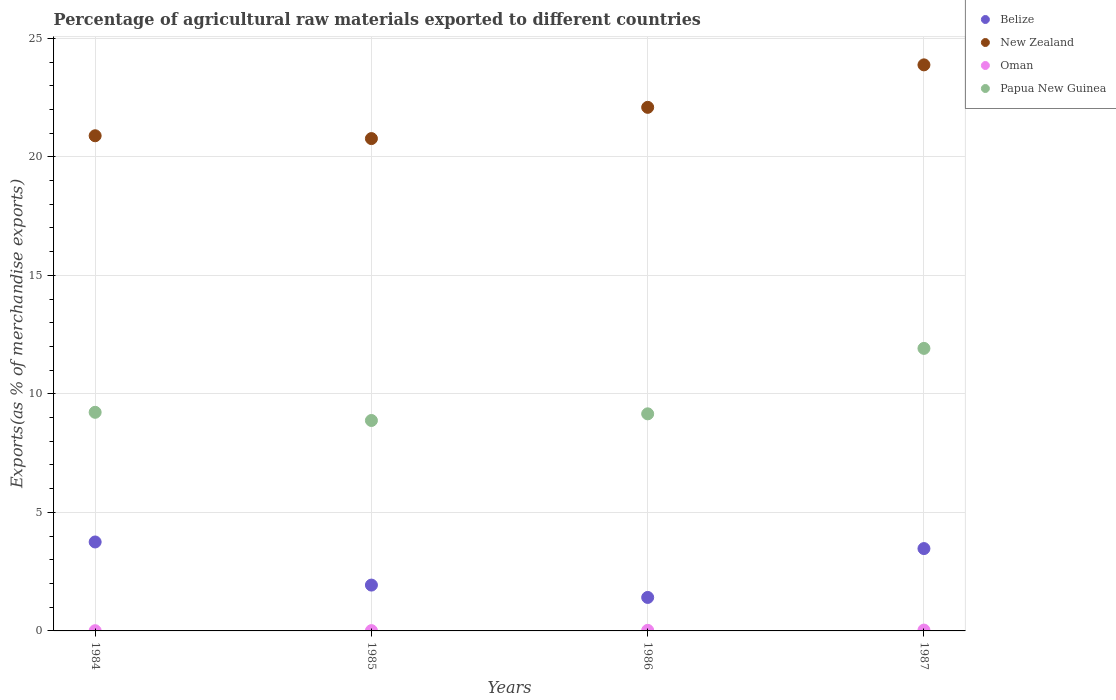What is the percentage of exports to different countries in Belize in 1986?
Give a very brief answer. 1.41. Across all years, what is the maximum percentage of exports to different countries in Belize?
Provide a short and direct response. 3.75. Across all years, what is the minimum percentage of exports to different countries in Oman?
Provide a succinct answer. 0.01. In which year was the percentage of exports to different countries in Belize maximum?
Ensure brevity in your answer.  1984. In which year was the percentage of exports to different countries in Oman minimum?
Give a very brief answer. 1984. What is the total percentage of exports to different countries in Papua New Guinea in the graph?
Keep it short and to the point. 39.18. What is the difference between the percentage of exports to different countries in Papua New Guinea in 1984 and that in 1987?
Provide a short and direct response. -2.7. What is the difference between the percentage of exports to different countries in Belize in 1984 and the percentage of exports to different countries in New Zealand in 1986?
Your answer should be very brief. -18.34. What is the average percentage of exports to different countries in Belize per year?
Provide a succinct answer. 2.64. In the year 1984, what is the difference between the percentage of exports to different countries in Papua New Guinea and percentage of exports to different countries in Belize?
Give a very brief answer. 5.47. In how many years, is the percentage of exports to different countries in Belize greater than 10 %?
Ensure brevity in your answer.  0. What is the ratio of the percentage of exports to different countries in Oman in 1985 to that in 1987?
Keep it short and to the point. 0.35. Is the difference between the percentage of exports to different countries in Papua New Guinea in 1986 and 1987 greater than the difference between the percentage of exports to different countries in Belize in 1986 and 1987?
Keep it short and to the point. No. What is the difference between the highest and the second highest percentage of exports to different countries in Papua New Guinea?
Your answer should be compact. 2.7. What is the difference between the highest and the lowest percentage of exports to different countries in New Zealand?
Make the answer very short. 3.11. Is the sum of the percentage of exports to different countries in Papua New Guinea in 1985 and 1987 greater than the maximum percentage of exports to different countries in New Zealand across all years?
Your answer should be compact. No. Is the percentage of exports to different countries in Belize strictly greater than the percentage of exports to different countries in New Zealand over the years?
Offer a very short reply. No. Is the percentage of exports to different countries in Belize strictly less than the percentage of exports to different countries in Papua New Guinea over the years?
Provide a succinct answer. Yes. How many dotlines are there?
Keep it short and to the point. 4. Does the graph contain any zero values?
Your answer should be compact. No. How are the legend labels stacked?
Your answer should be compact. Vertical. What is the title of the graph?
Provide a short and direct response. Percentage of agricultural raw materials exported to different countries. What is the label or title of the X-axis?
Provide a short and direct response. Years. What is the label or title of the Y-axis?
Ensure brevity in your answer.  Exports(as % of merchandise exports). What is the Exports(as % of merchandise exports) in Belize in 1984?
Your answer should be very brief. 3.75. What is the Exports(as % of merchandise exports) in New Zealand in 1984?
Ensure brevity in your answer.  20.89. What is the Exports(as % of merchandise exports) of Oman in 1984?
Your answer should be very brief. 0.01. What is the Exports(as % of merchandise exports) in Papua New Guinea in 1984?
Give a very brief answer. 9.22. What is the Exports(as % of merchandise exports) in Belize in 1985?
Keep it short and to the point. 1.93. What is the Exports(as % of merchandise exports) of New Zealand in 1985?
Your response must be concise. 20.77. What is the Exports(as % of merchandise exports) in Oman in 1985?
Your response must be concise. 0.01. What is the Exports(as % of merchandise exports) of Papua New Guinea in 1985?
Keep it short and to the point. 8.88. What is the Exports(as % of merchandise exports) in Belize in 1986?
Ensure brevity in your answer.  1.41. What is the Exports(as % of merchandise exports) of New Zealand in 1986?
Make the answer very short. 22.09. What is the Exports(as % of merchandise exports) of Oman in 1986?
Give a very brief answer. 0.02. What is the Exports(as % of merchandise exports) of Papua New Guinea in 1986?
Ensure brevity in your answer.  9.16. What is the Exports(as % of merchandise exports) of Belize in 1987?
Give a very brief answer. 3.47. What is the Exports(as % of merchandise exports) in New Zealand in 1987?
Your answer should be very brief. 23.88. What is the Exports(as % of merchandise exports) of Oman in 1987?
Provide a succinct answer. 0.04. What is the Exports(as % of merchandise exports) in Papua New Guinea in 1987?
Keep it short and to the point. 11.92. Across all years, what is the maximum Exports(as % of merchandise exports) in Belize?
Provide a succinct answer. 3.75. Across all years, what is the maximum Exports(as % of merchandise exports) in New Zealand?
Your answer should be very brief. 23.88. Across all years, what is the maximum Exports(as % of merchandise exports) of Oman?
Offer a very short reply. 0.04. Across all years, what is the maximum Exports(as % of merchandise exports) in Papua New Guinea?
Offer a very short reply. 11.92. Across all years, what is the minimum Exports(as % of merchandise exports) in Belize?
Keep it short and to the point. 1.41. Across all years, what is the minimum Exports(as % of merchandise exports) in New Zealand?
Give a very brief answer. 20.77. Across all years, what is the minimum Exports(as % of merchandise exports) of Oman?
Make the answer very short. 0.01. Across all years, what is the minimum Exports(as % of merchandise exports) in Papua New Guinea?
Provide a short and direct response. 8.88. What is the total Exports(as % of merchandise exports) of Belize in the graph?
Offer a terse response. 10.57. What is the total Exports(as % of merchandise exports) in New Zealand in the graph?
Your response must be concise. 87.62. What is the total Exports(as % of merchandise exports) in Oman in the graph?
Provide a short and direct response. 0.08. What is the total Exports(as % of merchandise exports) of Papua New Guinea in the graph?
Your answer should be very brief. 39.18. What is the difference between the Exports(as % of merchandise exports) in Belize in 1984 and that in 1985?
Give a very brief answer. 1.82. What is the difference between the Exports(as % of merchandise exports) of New Zealand in 1984 and that in 1985?
Provide a succinct answer. 0.12. What is the difference between the Exports(as % of merchandise exports) in Oman in 1984 and that in 1985?
Ensure brevity in your answer.  -0. What is the difference between the Exports(as % of merchandise exports) of Papua New Guinea in 1984 and that in 1985?
Make the answer very short. 0.35. What is the difference between the Exports(as % of merchandise exports) of Belize in 1984 and that in 1986?
Provide a short and direct response. 2.34. What is the difference between the Exports(as % of merchandise exports) in New Zealand in 1984 and that in 1986?
Offer a very short reply. -1.2. What is the difference between the Exports(as % of merchandise exports) in Oman in 1984 and that in 1986?
Your answer should be very brief. -0.02. What is the difference between the Exports(as % of merchandise exports) in Papua New Guinea in 1984 and that in 1986?
Provide a short and direct response. 0.06. What is the difference between the Exports(as % of merchandise exports) of Belize in 1984 and that in 1987?
Give a very brief answer. 0.28. What is the difference between the Exports(as % of merchandise exports) of New Zealand in 1984 and that in 1987?
Your answer should be compact. -2.99. What is the difference between the Exports(as % of merchandise exports) in Oman in 1984 and that in 1987?
Provide a short and direct response. -0.03. What is the difference between the Exports(as % of merchandise exports) in Papua New Guinea in 1984 and that in 1987?
Provide a short and direct response. -2.7. What is the difference between the Exports(as % of merchandise exports) in Belize in 1985 and that in 1986?
Ensure brevity in your answer.  0.52. What is the difference between the Exports(as % of merchandise exports) in New Zealand in 1985 and that in 1986?
Your answer should be compact. -1.32. What is the difference between the Exports(as % of merchandise exports) of Oman in 1985 and that in 1986?
Make the answer very short. -0.01. What is the difference between the Exports(as % of merchandise exports) of Papua New Guinea in 1985 and that in 1986?
Ensure brevity in your answer.  -0.28. What is the difference between the Exports(as % of merchandise exports) of Belize in 1985 and that in 1987?
Keep it short and to the point. -1.54. What is the difference between the Exports(as % of merchandise exports) in New Zealand in 1985 and that in 1987?
Provide a succinct answer. -3.11. What is the difference between the Exports(as % of merchandise exports) of Oman in 1985 and that in 1987?
Make the answer very short. -0.02. What is the difference between the Exports(as % of merchandise exports) of Papua New Guinea in 1985 and that in 1987?
Ensure brevity in your answer.  -3.04. What is the difference between the Exports(as % of merchandise exports) in Belize in 1986 and that in 1987?
Make the answer very short. -2.06. What is the difference between the Exports(as % of merchandise exports) of New Zealand in 1986 and that in 1987?
Keep it short and to the point. -1.79. What is the difference between the Exports(as % of merchandise exports) in Oman in 1986 and that in 1987?
Ensure brevity in your answer.  -0.01. What is the difference between the Exports(as % of merchandise exports) in Papua New Guinea in 1986 and that in 1987?
Your answer should be very brief. -2.76. What is the difference between the Exports(as % of merchandise exports) in Belize in 1984 and the Exports(as % of merchandise exports) in New Zealand in 1985?
Provide a succinct answer. -17.02. What is the difference between the Exports(as % of merchandise exports) of Belize in 1984 and the Exports(as % of merchandise exports) of Oman in 1985?
Make the answer very short. 3.74. What is the difference between the Exports(as % of merchandise exports) of Belize in 1984 and the Exports(as % of merchandise exports) of Papua New Guinea in 1985?
Provide a succinct answer. -5.12. What is the difference between the Exports(as % of merchandise exports) in New Zealand in 1984 and the Exports(as % of merchandise exports) in Oman in 1985?
Ensure brevity in your answer.  20.88. What is the difference between the Exports(as % of merchandise exports) of New Zealand in 1984 and the Exports(as % of merchandise exports) of Papua New Guinea in 1985?
Your response must be concise. 12.01. What is the difference between the Exports(as % of merchandise exports) of Oman in 1984 and the Exports(as % of merchandise exports) of Papua New Guinea in 1985?
Your response must be concise. -8.87. What is the difference between the Exports(as % of merchandise exports) of Belize in 1984 and the Exports(as % of merchandise exports) of New Zealand in 1986?
Provide a short and direct response. -18.34. What is the difference between the Exports(as % of merchandise exports) of Belize in 1984 and the Exports(as % of merchandise exports) of Oman in 1986?
Your answer should be compact. 3.73. What is the difference between the Exports(as % of merchandise exports) in Belize in 1984 and the Exports(as % of merchandise exports) in Papua New Guinea in 1986?
Offer a very short reply. -5.41. What is the difference between the Exports(as % of merchandise exports) of New Zealand in 1984 and the Exports(as % of merchandise exports) of Oman in 1986?
Make the answer very short. 20.86. What is the difference between the Exports(as % of merchandise exports) of New Zealand in 1984 and the Exports(as % of merchandise exports) of Papua New Guinea in 1986?
Provide a short and direct response. 11.73. What is the difference between the Exports(as % of merchandise exports) of Oman in 1984 and the Exports(as % of merchandise exports) of Papua New Guinea in 1986?
Make the answer very short. -9.15. What is the difference between the Exports(as % of merchandise exports) of Belize in 1984 and the Exports(as % of merchandise exports) of New Zealand in 1987?
Keep it short and to the point. -20.13. What is the difference between the Exports(as % of merchandise exports) of Belize in 1984 and the Exports(as % of merchandise exports) of Oman in 1987?
Offer a very short reply. 3.72. What is the difference between the Exports(as % of merchandise exports) in Belize in 1984 and the Exports(as % of merchandise exports) in Papua New Guinea in 1987?
Offer a terse response. -8.17. What is the difference between the Exports(as % of merchandise exports) in New Zealand in 1984 and the Exports(as % of merchandise exports) in Oman in 1987?
Provide a succinct answer. 20.85. What is the difference between the Exports(as % of merchandise exports) in New Zealand in 1984 and the Exports(as % of merchandise exports) in Papua New Guinea in 1987?
Offer a very short reply. 8.97. What is the difference between the Exports(as % of merchandise exports) of Oman in 1984 and the Exports(as % of merchandise exports) of Papua New Guinea in 1987?
Offer a terse response. -11.91. What is the difference between the Exports(as % of merchandise exports) of Belize in 1985 and the Exports(as % of merchandise exports) of New Zealand in 1986?
Make the answer very short. -20.15. What is the difference between the Exports(as % of merchandise exports) of Belize in 1985 and the Exports(as % of merchandise exports) of Oman in 1986?
Your answer should be compact. 1.91. What is the difference between the Exports(as % of merchandise exports) of Belize in 1985 and the Exports(as % of merchandise exports) of Papua New Guinea in 1986?
Keep it short and to the point. -7.22. What is the difference between the Exports(as % of merchandise exports) in New Zealand in 1985 and the Exports(as % of merchandise exports) in Oman in 1986?
Your response must be concise. 20.74. What is the difference between the Exports(as % of merchandise exports) in New Zealand in 1985 and the Exports(as % of merchandise exports) in Papua New Guinea in 1986?
Your response must be concise. 11.61. What is the difference between the Exports(as % of merchandise exports) in Oman in 1985 and the Exports(as % of merchandise exports) in Papua New Guinea in 1986?
Offer a terse response. -9.15. What is the difference between the Exports(as % of merchandise exports) in Belize in 1985 and the Exports(as % of merchandise exports) in New Zealand in 1987?
Provide a short and direct response. -21.95. What is the difference between the Exports(as % of merchandise exports) of Belize in 1985 and the Exports(as % of merchandise exports) of Oman in 1987?
Your answer should be compact. 1.9. What is the difference between the Exports(as % of merchandise exports) of Belize in 1985 and the Exports(as % of merchandise exports) of Papua New Guinea in 1987?
Give a very brief answer. -9.99. What is the difference between the Exports(as % of merchandise exports) in New Zealand in 1985 and the Exports(as % of merchandise exports) in Oman in 1987?
Keep it short and to the point. 20.73. What is the difference between the Exports(as % of merchandise exports) in New Zealand in 1985 and the Exports(as % of merchandise exports) in Papua New Guinea in 1987?
Make the answer very short. 8.85. What is the difference between the Exports(as % of merchandise exports) in Oman in 1985 and the Exports(as % of merchandise exports) in Papua New Guinea in 1987?
Your response must be concise. -11.91. What is the difference between the Exports(as % of merchandise exports) in Belize in 1986 and the Exports(as % of merchandise exports) in New Zealand in 1987?
Your response must be concise. -22.47. What is the difference between the Exports(as % of merchandise exports) in Belize in 1986 and the Exports(as % of merchandise exports) in Oman in 1987?
Your response must be concise. 1.38. What is the difference between the Exports(as % of merchandise exports) in Belize in 1986 and the Exports(as % of merchandise exports) in Papua New Guinea in 1987?
Give a very brief answer. -10.51. What is the difference between the Exports(as % of merchandise exports) of New Zealand in 1986 and the Exports(as % of merchandise exports) of Oman in 1987?
Your response must be concise. 22.05. What is the difference between the Exports(as % of merchandise exports) of New Zealand in 1986 and the Exports(as % of merchandise exports) of Papua New Guinea in 1987?
Give a very brief answer. 10.17. What is the difference between the Exports(as % of merchandise exports) in Oman in 1986 and the Exports(as % of merchandise exports) in Papua New Guinea in 1987?
Make the answer very short. -11.89. What is the average Exports(as % of merchandise exports) in Belize per year?
Offer a very short reply. 2.64. What is the average Exports(as % of merchandise exports) of New Zealand per year?
Offer a very short reply. 21.91. What is the average Exports(as % of merchandise exports) of Oman per year?
Your answer should be very brief. 0.02. What is the average Exports(as % of merchandise exports) in Papua New Guinea per year?
Give a very brief answer. 9.79. In the year 1984, what is the difference between the Exports(as % of merchandise exports) in Belize and Exports(as % of merchandise exports) in New Zealand?
Give a very brief answer. -17.14. In the year 1984, what is the difference between the Exports(as % of merchandise exports) of Belize and Exports(as % of merchandise exports) of Oman?
Provide a short and direct response. 3.74. In the year 1984, what is the difference between the Exports(as % of merchandise exports) of Belize and Exports(as % of merchandise exports) of Papua New Guinea?
Ensure brevity in your answer.  -5.47. In the year 1984, what is the difference between the Exports(as % of merchandise exports) in New Zealand and Exports(as % of merchandise exports) in Oman?
Your response must be concise. 20.88. In the year 1984, what is the difference between the Exports(as % of merchandise exports) of New Zealand and Exports(as % of merchandise exports) of Papua New Guinea?
Your answer should be compact. 11.67. In the year 1984, what is the difference between the Exports(as % of merchandise exports) of Oman and Exports(as % of merchandise exports) of Papua New Guinea?
Your answer should be very brief. -9.21. In the year 1985, what is the difference between the Exports(as % of merchandise exports) in Belize and Exports(as % of merchandise exports) in New Zealand?
Your answer should be very brief. -18.84. In the year 1985, what is the difference between the Exports(as % of merchandise exports) in Belize and Exports(as % of merchandise exports) in Oman?
Your answer should be very brief. 1.92. In the year 1985, what is the difference between the Exports(as % of merchandise exports) of Belize and Exports(as % of merchandise exports) of Papua New Guinea?
Provide a succinct answer. -6.94. In the year 1985, what is the difference between the Exports(as % of merchandise exports) in New Zealand and Exports(as % of merchandise exports) in Oman?
Your response must be concise. 20.76. In the year 1985, what is the difference between the Exports(as % of merchandise exports) in New Zealand and Exports(as % of merchandise exports) in Papua New Guinea?
Give a very brief answer. 11.89. In the year 1985, what is the difference between the Exports(as % of merchandise exports) of Oman and Exports(as % of merchandise exports) of Papua New Guinea?
Offer a very short reply. -8.86. In the year 1986, what is the difference between the Exports(as % of merchandise exports) in Belize and Exports(as % of merchandise exports) in New Zealand?
Ensure brevity in your answer.  -20.68. In the year 1986, what is the difference between the Exports(as % of merchandise exports) of Belize and Exports(as % of merchandise exports) of Oman?
Make the answer very short. 1.39. In the year 1986, what is the difference between the Exports(as % of merchandise exports) of Belize and Exports(as % of merchandise exports) of Papua New Guinea?
Your answer should be compact. -7.75. In the year 1986, what is the difference between the Exports(as % of merchandise exports) in New Zealand and Exports(as % of merchandise exports) in Oman?
Keep it short and to the point. 22.06. In the year 1986, what is the difference between the Exports(as % of merchandise exports) of New Zealand and Exports(as % of merchandise exports) of Papua New Guinea?
Ensure brevity in your answer.  12.93. In the year 1986, what is the difference between the Exports(as % of merchandise exports) in Oman and Exports(as % of merchandise exports) in Papua New Guinea?
Make the answer very short. -9.13. In the year 1987, what is the difference between the Exports(as % of merchandise exports) of Belize and Exports(as % of merchandise exports) of New Zealand?
Offer a terse response. -20.41. In the year 1987, what is the difference between the Exports(as % of merchandise exports) in Belize and Exports(as % of merchandise exports) in Oman?
Your response must be concise. 3.44. In the year 1987, what is the difference between the Exports(as % of merchandise exports) of Belize and Exports(as % of merchandise exports) of Papua New Guinea?
Offer a very short reply. -8.44. In the year 1987, what is the difference between the Exports(as % of merchandise exports) in New Zealand and Exports(as % of merchandise exports) in Oman?
Provide a short and direct response. 23.84. In the year 1987, what is the difference between the Exports(as % of merchandise exports) in New Zealand and Exports(as % of merchandise exports) in Papua New Guinea?
Offer a terse response. 11.96. In the year 1987, what is the difference between the Exports(as % of merchandise exports) in Oman and Exports(as % of merchandise exports) in Papua New Guinea?
Your answer should be compact. -11.88. What is the ratio of the Exports(as % of merchandise exports) of Belize in 1984 to that in 1985?
Keep it short and to the point. 1.94. What is the ratio of the Exports(as % of merchandise exports) of Oman in 1984 to that in 1985?
Your answer should be very brief. 0.74. What is the ratio of the Exports(as % of merchandise exports) in Papua New Guinea in 1984 to that in 1985?
Make the answer very short. 1.04. What is the ratio of the Exports(as % of merchandise exports) of Belize in 1984 to that in 1986?
Make the answer very short. 2.66. What is the ratio of the Exports(as % of merchandise exports) of New Zealand in 1984 to that in 1986?
Provide a short and direct response. 0.95. What is the ratio of the Exports(as % of merchandise exports) in Oman in 1984 to that in 1986?
Ensure brevity in your answer.  0.37. What is the ratio of the Exports(as % of merchandise exports) of Belize in 1984 to that in 1987?
Your answer should be compact. 1.08. What is the ratio of the Exports(as % of merchandise exports) of New Zealand in 1984 to that in 1987?
Provide a short and direct response. 0.87. What is the ratio of the Exports(as % of merchandise exports) of Oman in 1984 to that in 1987?
Ensure brevity in your answer.  0.26. What is the ratio of the Exports(as % of merchandise exports) in Papua New Guinea in 1984 to that in 1987?
Give a very brief answer. 0.77. What is the ratio of the Exports(as % of merchandise exports) in Belize in 1985 to that in 1986?
Ensure brevity in your answer.  1.37. What is the ratio of the Exports(as % of merchandise exports) in New Zealand in 1985 to that in 1986?
Offer a very short reply. 0.94. What is the ratio of the Exports(as % of merchandise exports) in Oman in 1985 to that in 1986?
Make the answer very short. 0.5. What is the ratio of the Exports(as % of merchandise exports) in Papua New Guinea in 1985 to that in 1986?
Offer a very short reply. 0.97. What is the ratio of the Exports(as % of merchandise exports) in Belize in 1985 to that in 1987?
Provide a succinct answer. 0.56. What is the ratio of the Exports(as % of merchandise exports) of New Zealand in 1985 to that in 1987?
Provide a short and direct response. 0.87. What is the ratio of the Exports(as % of merchandise exports) of Oman in 1985 to that in 1987?
Provide a succinct answer. 0.35. What is the ratio of the Exports(as % of merchandise exports) in Papua New Guinea in 1985 to that in 1987?
Your answer should be compact. 0.74. What is the ratio of the Exports(as % of merchandise exports) in Belize in 1986 to that in 1987?
Provide a succinct answer. 0.41. What is the ratio of the Exports(as % of merchandise exports) of New Zealand in 1986 to that in 1987?
Keep it short and to the point. 0.93. What is the ratio of the Exports(as % of merchandise exports) of Oman in 1986 to that in 1987?
Provide a succinct answer. 0.69. What is the ratio of the Exports(as % of merchandise exports) of Papua New Guinea in 1986 to that in 1987?
Give a very brief answer. 0.77. What is the difference between the highest and the second highest Exports(as % of merchandise exports) in Belize?
Your response must be concise. 0.28. What is the difference between the highest and the second highest Exports(as % of merchandise exports) in New Zealand?
Offer a terse response. 1.79. What is the difference between the highest and the second highest Exports(as % of merchandise exports) of Oman?
Keep it short and to the point. 0.01. What is the difference between the highest and the second highest Exports(as % of merchandise exports) in Papua New Guinea?
Keep it short and to the point. 2.7. What is the difference between the highest and the lowest Exports(as % of merchandise exports) of Belize?
Provide a short and direct response. 2.34. What is the difference between the highest and the lowest Exports(as % of merchandise exports) in New Zealand?
Ensure brevity in your answer.  3.11. What is the difference between the highest and the lowest Exports(as % of merchandise exports) in Oman?
Provide a short and direct response. 0.03. What is the difference between the highest and the lowest Exports(as % of merchandise exports) of Papua New Guinea?
Keep it short and to the point. 3.04. 